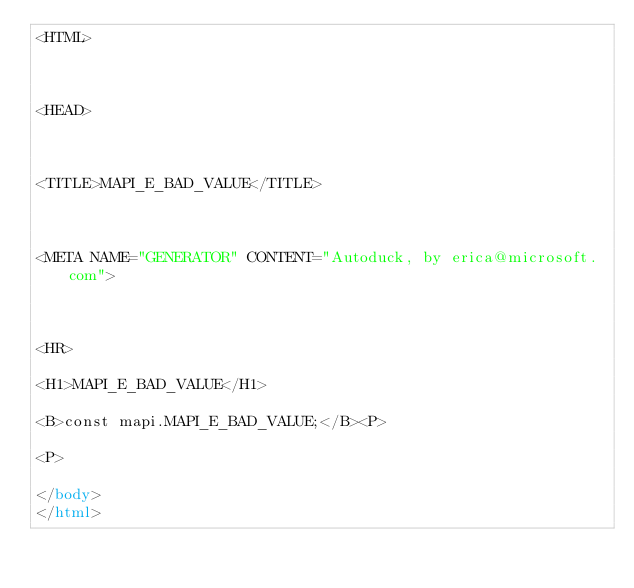Convert code to text. <code><loc_0><loc_0><loc_500><loc_500><_HTML_><HTML>



<HEAD>



<TITLE>MAPI_E_BAD_VALUE</TITLE>



<META NAME="GENERATOR" CONTENT="Autoduck, by erica@microsoft.com">



<HR>

<H1>MAPI_E_BAD_VALUE</H1>

<B>const mapi.MAPI_E_BAD_VALUE;</B><P>

<P>

</body>
</html></code> 